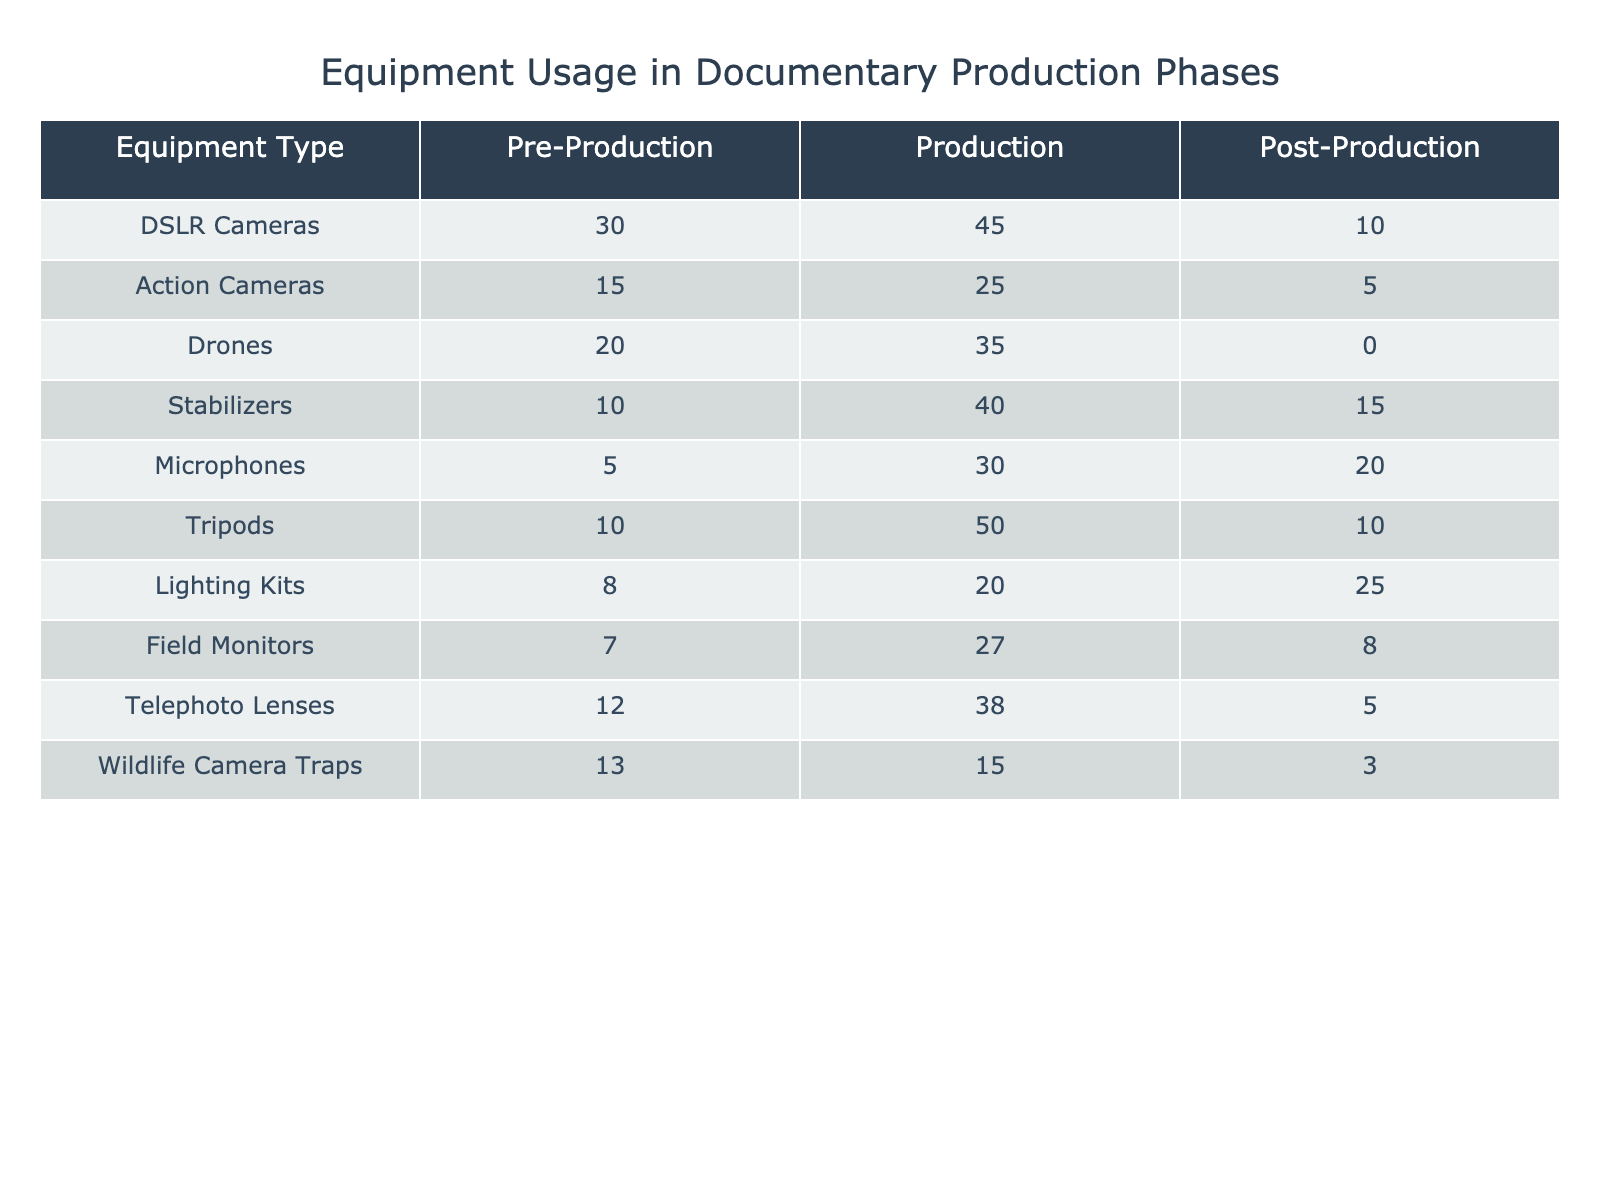What is the total number of DSLRs used in all production phases? To find the total number of DSLRs used across all phases, we need to add the values for DSLRs from each phase: 30 (Pre-Production) + 45 (Production) + 10 (Post-Production) = 85.
Answer: 85 Which equipment type was used the most during the Production phase? During the Production phase, we compare the values of all equipment types. The highest value is 50 for Tripods.
Answer: Tripods Is the usage of Drones during Post-Production greater than that of Action Cameras? The usage of Drones during Post-Production is 0, while Action Cameras were used 5 times in Post-Production. Since 0 is less than 5, the statement is false.
Answer: No What is the difference in the number of Microphones used between Pre-Production and Post-Production? To find the difference, we subtract the number of Microphones used in Post-Production (20) from that used in Pre-Production (5): 5 - 20 = -15. The absolute difference is 15.
Answer: 15 What is the average number of equipment used during the Production phase? To calculate the average, we sum the values during the Production phase for all equipment types (45 + 25 + 35 + 40 + 30 + 50 + 20 + 27 + 38 + 15) =  385, and then divide by the number of equipment types (10): 385 / 10 = 38.5.
Answer: 38.5 Which phase had the least usage overall? We determine the total usage for each phase: Pre-Production: 30 + 15 + 20 + 10 + 5 + 10 + 8 + 7 + 12 + 13 =  120, Production: 45 + 25 + 35 + 40 + 30 + 50 + 20 + 27 + 38 + 15 =  385, Post-Production: 10 + 5 + 0 + 15 + 20 + 10 + 25 + 8 + 5 + 3 =  103. The least usage is 103 in Post-Production.
Answer: Post-Production Are Lighting Kits the only equipment type used in the Post-Production phase? We need to check the values for all equipment types in the Post-Production phase. Since values are greater than 0 for Microphones (20) and Lighting Kits (25), the statement is false.
Answer: No What equipment type had the highest total usage across all phases? We calculate the total usage for each equipment type by summing their values across all phases. DSLRs: 85, Action Cameras: 45, Drones: 55, Stabilizers: 65, Microphones: 55, Tripods: 70, Lighting Kits: 53, Field Monitors: 62, Telephoto Lenses: 55, Wildlife Camera Traps: 31. Thus, DSLRs had the highest total usage at 85.
Answer: DSLRs 